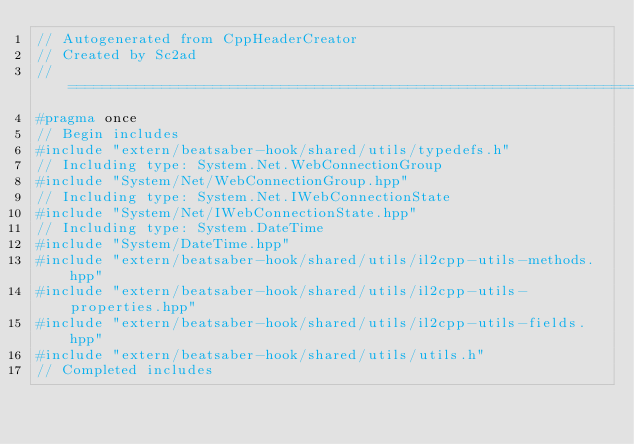Convert code to text. <code><loc_0><loc_0><loc_500><loc_500><_C++_>// Autogenerated from CppHeaderCreator
// Created by Sc2ad
// =========================================================================
#pragma once
// Begin includes
#include "extern/beatsaber-hook/shared/utils/typedefs.h"
// Including type: System.Net.WebConnectionGroup
#include "System/Net/WebConnectionGroup.hpp"
// Including type: System.Net.IWebConnectionState
#include "System/Net/IWebConnectionState.hpp"
// Including type: System.DateTime
#include "System/DateTime.hpp"
#include "extern/beatsaber-hook/shared/utils/il2cpp-utils-methods.hpp"
#include "extern/beatsaber-hook/shared/utils/il2cpp-utils-properties.hpp"
#include "extern/beatsaber-hook/shared/utils/il2cpp-utils-fields.hpp"
#include "extern/beatsaber-hook/shared/utils/utils.h"
// Completed includes</code> 